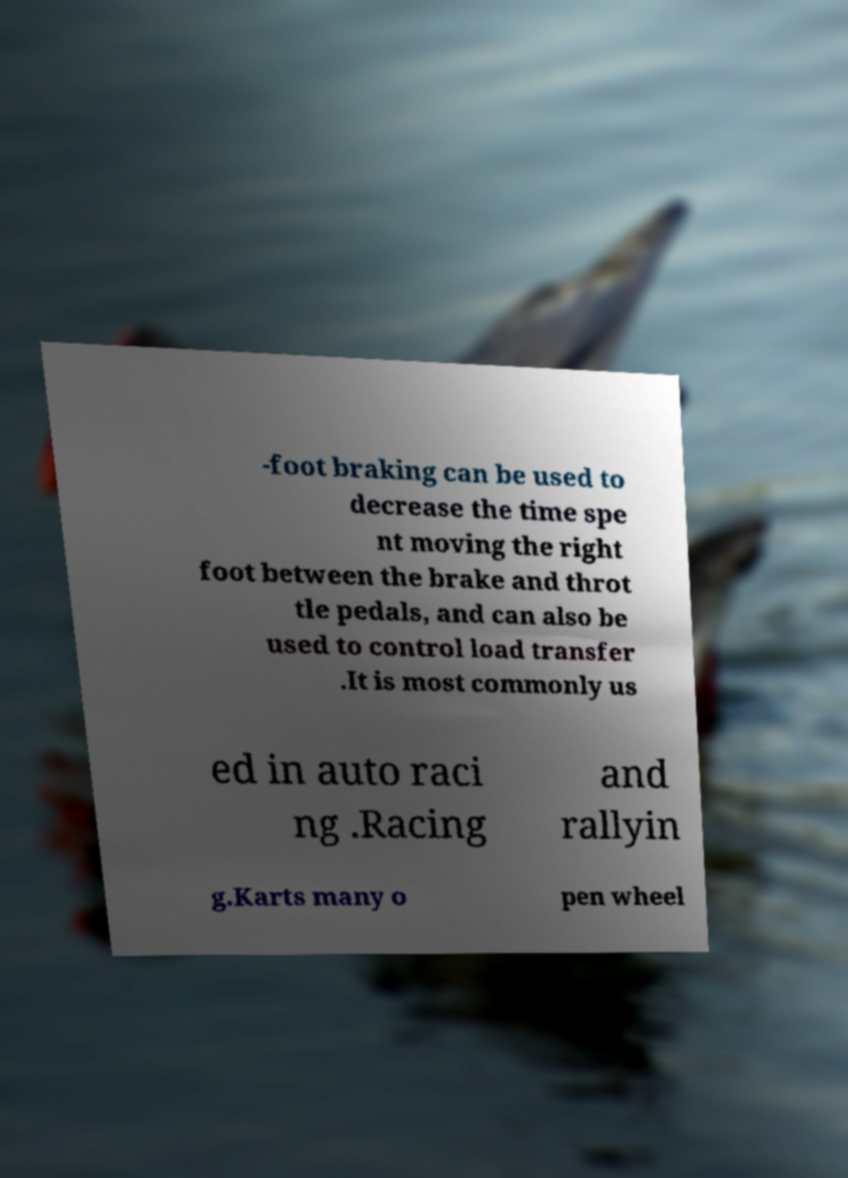Can you accurately transcribe the text from the provided image for me? -foot braking can be used to decrease the time spe nt moving the right foot between the brake and throt tle pedals, and can also be used to control load transfer .It is most commonly us ed in auto raci ng .Racing and rallyin g.Karts many o pen wheel 